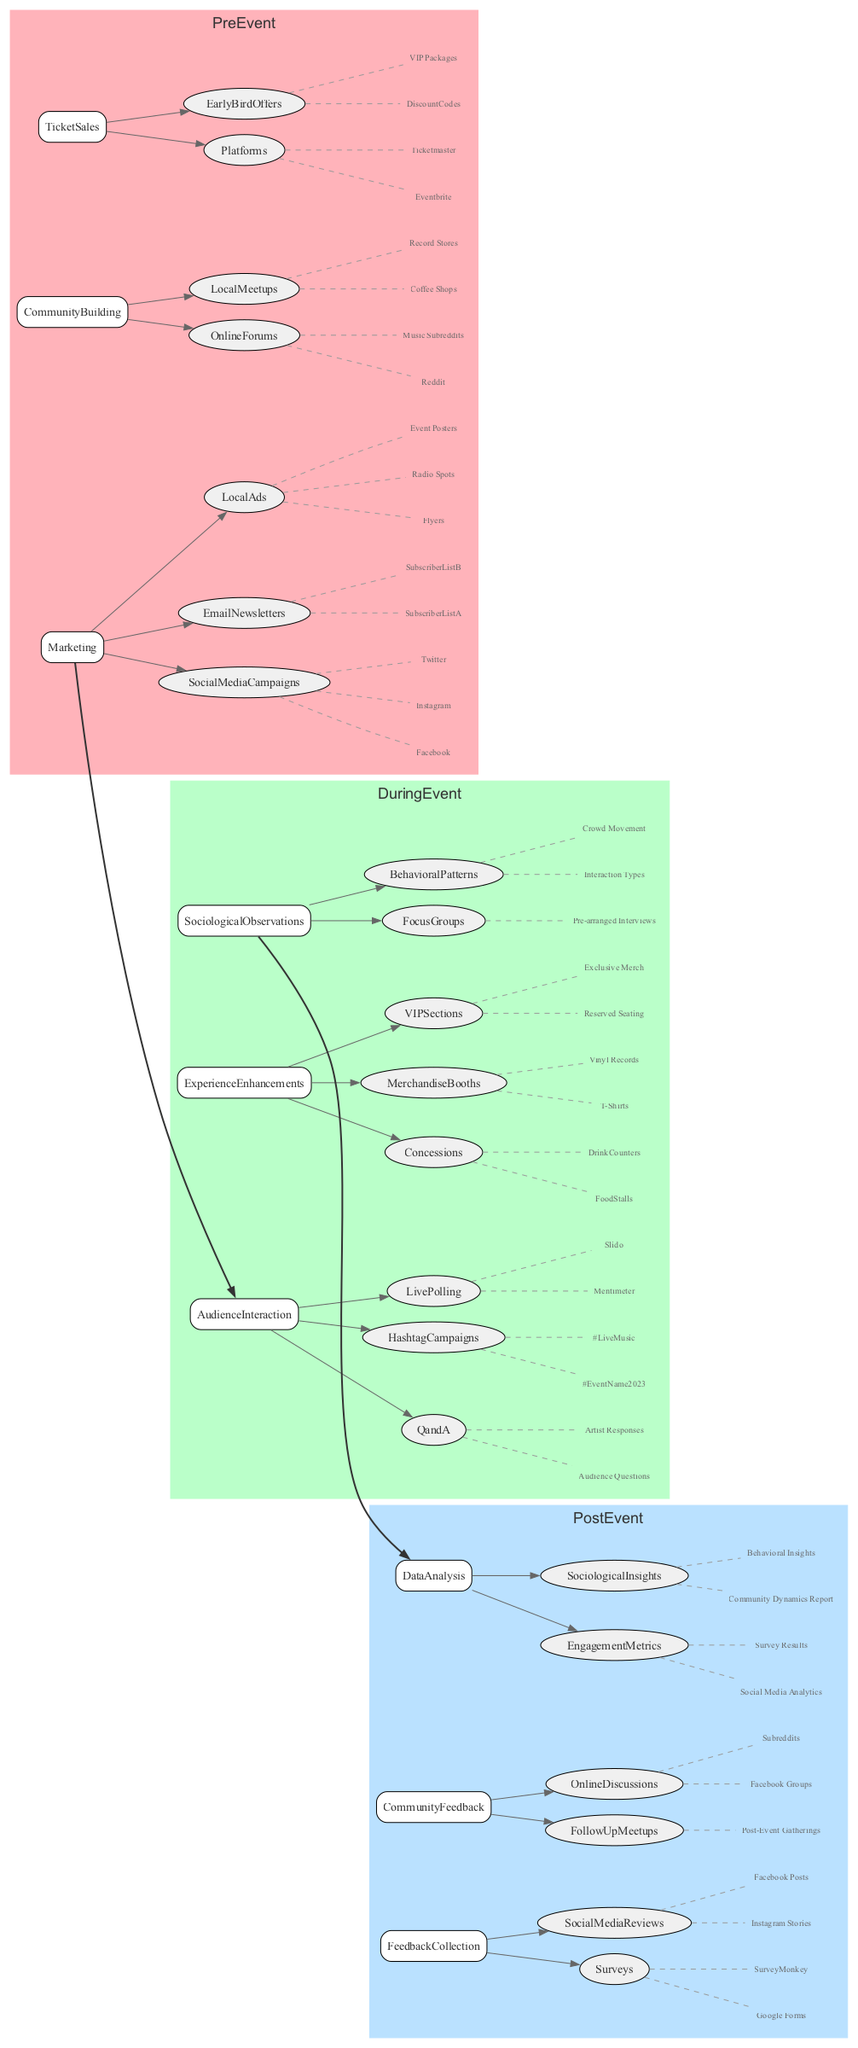What are the platforms used for Ticket Sales in the Pre-Event stage? In the Pre-Event stage, Ticket Sales are listed under a specific category that includes a node for Platforms. By inspecting this node, we see the items listed are Eventbrite and Ticketmaster.
Answer: Eventbrite, Ticketmaster How many types of Audience Interaction are there during the event? Looking at the During Event stage under Audience Interaction, we can count the listed interactions: Live Polling, Q and A, and Hashtag Campaigns. This gives us a total of three types.
Answer: 3 What is the color used for the Post-Event stage? The color assigned to the Post-Event stage can be found in the subgraph attributes. It is noted that the color is specified as #BAE1FF.
Answer: #BAE1FF Which platforms are mentioned for Feedback Collection in the Post-Event stage? Referring to the Feedback Collection category under Post-Event, we can identify that the platforms listed are Google Forms and SurveyMonkey.
Answer: Google Forms, SurveyMonkey What connects the During Event Sociological Observations to the Post Event Data Analysis? By analyzing the edges and nodes, we see a direct bold connection from During Event Sociological Observations to Post Event Data Analysis, indicating that sociological insights gathered during the event feed directly into data analysis afterward.
Answer: Post Event Data Analysis How does Community Building in the Pre-Event phase influence the Audience Interaction during the event? To answer this, we track the connection from Community Building in Pre-Event to Audience Interaction in During Event. Since Community Building is positioned to generate interest and engagement before the event, this directly influences the level of interaction resulting from that pre-existing community engagement during the event.
Answer: Increases interaction levels What are the main enhancements offered during the event? In the During Event stage, the Experience Enhancements category is reviewed, which includes VIP Sections, Concessions, and Merchandise Booths as the main offerings for attendees.
Answer: VIP Sections, Concessions, Merchandise Booths How many sociological observations are listed during the event? By looking under the Sociological Observations category in the During Event stage, we find two types: Focus Groups and Behavioral Patterns. This means there are a total of two sociological observations listed.
Answer: 2 What method is used for community feedback in the Post-Event stage? Upon checking the Community Feedback category, we notice it refers to Follow-Up Meetups and Online Discussions. Therefore, community feedback is gathered through these methods.
Answer: Follow-Up Meetups, Online Discussions 